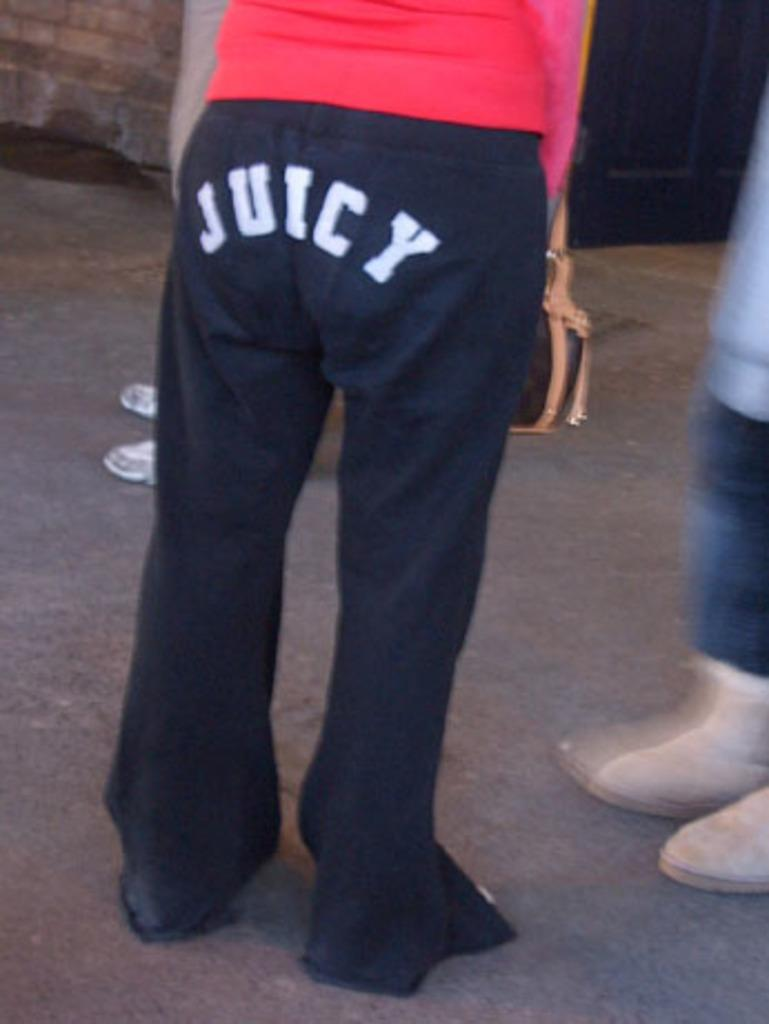<image>
Create a compact narrative representing the image presented. A person wears blue pants with Juicy on the butt. 